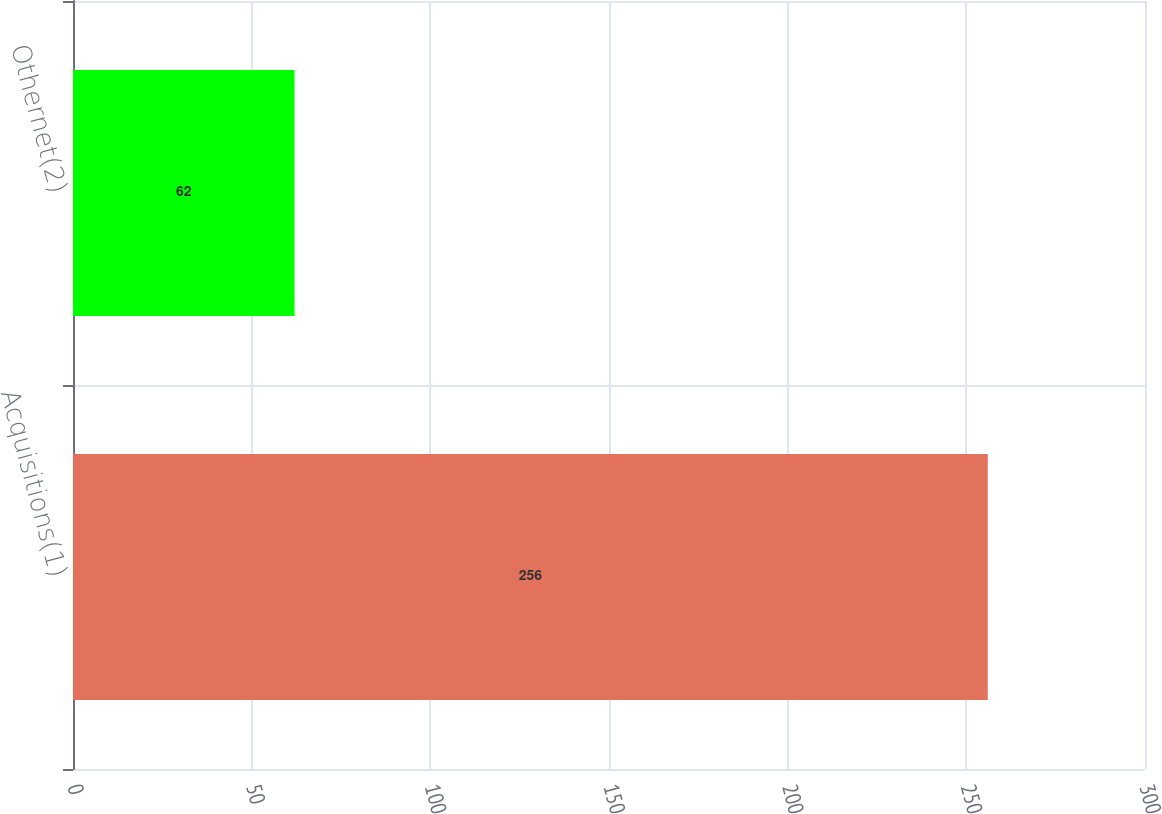Convert chart to OTSL. <chart><loc_0><loc_0><loc_500><loc_500><bar_chart><fcel>Acquisitions(1)<fcel>Othernet(2)<nl><fcel>256<fcel>62<nl></chart> 